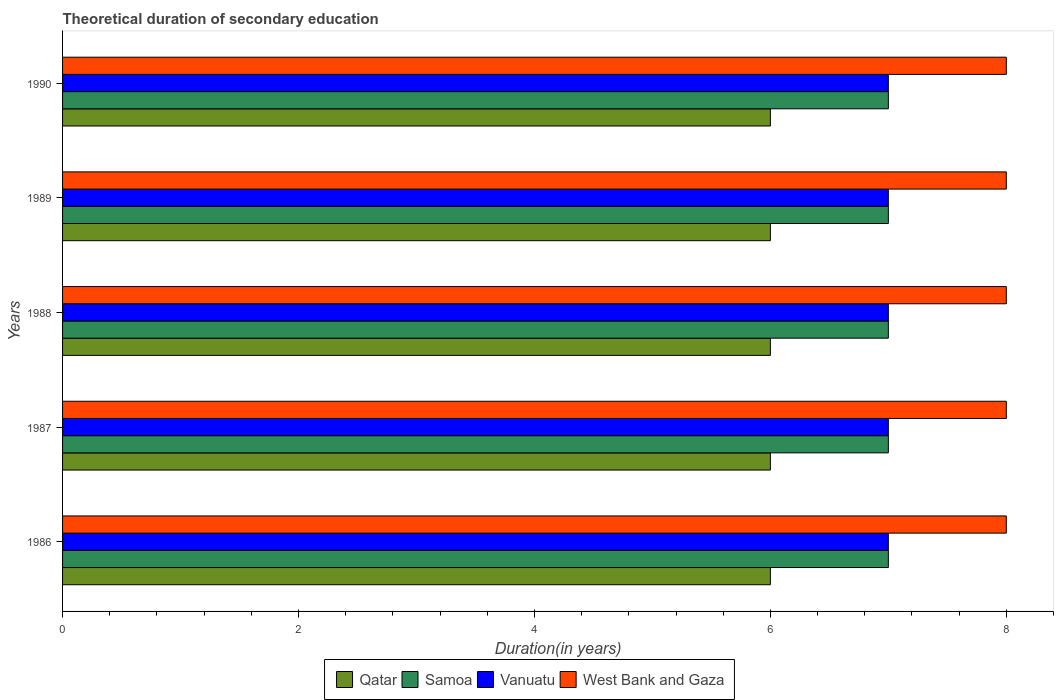How many different coloured bars are there?
Give a very brief answer. 4. Are the number of bars per tick equal to the number of legend labels?
Offer a terse response. Yes. How many bars are there on the 5th tick from the top?
Ensure brevity in your answer.  4. What is the label of the 1st group of bars from the top?
Your response must be concise. 1990. In how many cases, is the number of bars for a given year not equal to the number of legend labels?
Ensure brevity in your answer.  0. What is the total theoretical duration of secondary education in West Bank and Gaza in 1987?
Ensure brevity in your answer.  8. Across all years, what is the maximum total theoretical duration of secondary education in Vanuatu?
Give a very brief answer. 7. Across all years, what is the minimum total theoretical duration of secondary education in West Bank and Gaza?
Your answer should be compact. 8. In which year was the total theoretical duration of secondary education in West Bank and Gaza minimum?
Your answer should be compact. 1986. What is the total total theoretical duration of secondary education in Qatar in the graph?
Provide a succinct answer. 30. What is the difference between the total theoretical duration of secondary education in Samoa in 1988 and that in 1990?
Give a very brief answer. 0. What is the difference between the total theoretical duration of secondary education in West Bank and Gaza in 1989 and the total theoretical duration of secondary education in Vanuatu in 1986?
Provide a succinct answer. 1. In the year 1990, what is the difference between the total theoretical duration of secondary education in Vanuatu and total theoretical duration of secondary education in West Bank and Gaza?
Provide a short and direct response. -1. What is the ratio of the total theoretical duration of secondary education in Qatar in 1986 to that in 1990?
Provide a short and direct response. 1. Is the difference between the total theoretical duration of secondary education in Vanuatu in 1988 and 1990 greater than the difference between the total theoretical duration of secondary education in West Bank and Gaza in 1988 and 1990?
Your answer should be very brief. No. What is the difference between the highest and the second highest total theoretical duration of secondary education in Qatar?
Provide a short and direct response. 0. Is it the case that in every year, the sum of the total theoretical duration of secondary education in Samoa and total theoretical duration of secondary education in West Bank and Gaza is greater than the sum of total theoretical duration of secondary education in Vanuatu and total theoretical duration of secondary education in Qatar?
Make the answer very short. No. What does the 2nd bar from the top in 1986 represents?
Provide a succinct answer. Vanuatu. What does the 3rd bar from the bottom in 1990 represents?
Offer a very short reply. Vanuatu. How many bars are there?
Offer a very short reply. 20. Are all the bars in the graph horizontal?
Offer a terse response. Yes. Does the graph contain any zero values?
Provide a short and direct response. No. Does the graph contain grids?
Give a very brief answer. No. How are the legend labels stacked?
Offer a very short reply. Horizontal. What is the title of the graph?
Make the answer very short. Theoretical duration of secondary education. What is the label or title of the X-axis?
Give a very brief answer. Duration(in years). What is the label or title of the Y-axis?
Your answer should be very brief. Years. What is the Duration(in years) of Qatar in 1986?
Keep it short and to the point. 6. What is the Duration(in years) in Vanuatu in 1986?
Offer a terse response. 7. What is the Duration(in years) in Qatar in 1987?
Your answer should be compact. 6. What is the Duration(in years) of Vanuatu in 1987?
Your answer should be very brief. 7. What is the Duration(in years) in Vanuatu in 1988?
Your response must be concise. 7. What is the Duration(in years) in Vanuatu in 1990?
Your answer should be compact. 7. What is the Duration(in years) of West Bank and Gaza in 1990?
Make the answer very short. 8. Across all years, what is the maximum Duration(in years) of Qatar?
Offer a very short reply. 6. Across all years, what is the maximum Duration(in years) of Vanuatu?
Keep it short and to the point. 7. Across all years, what is the minimum Duration(in years) in Qatar?
Provide a short and direct response. 6. Across all years, what is the minimum Duration(in years) of West Bank and Gaza?
Provide a succinct answer. 8. What is the total Duration(in years) in Qatar in the graph?
Provide a succinct answer. 30. What is the total Duration(in years) in Samoa in the graph?
Make the answer very short. 35. What is the total Duration(in years) in Vanuatu in the graph?
Offer a terse response. 35. What is the difference between the Duration(in years) of Samoa in 1986 and that in 1987?
Your response must be concise. 0. What is the difference between the Duration(in years) of Vanuatu in 1986 and that in 1987?
Keep it short and to the point. 0. What is the difference between the Duration(in years) in West Bank and Gaza in 1986 and that in 1987?
Offer a terse response. 0. What is the difference between the Duration(in years) in Qatar in 1986 and that in 1988?
Give a very brief answer. 0. What is the difference between the Duration(in years) in Samoa in 1986 and that in 1988?
Your answer should be compact. 0. What is the difference between the Duration(in years) in Vanuatu in 1986 and that in 1988?
Your response must be concise. 0. What is the difference between the Duration(in years) in Samoa in 1986 and that in 1989?
Your answer should be compact. 0. What is the difference between the Duration(in years) in Vanuatu in 1986 and that in 1989?
Your answer should be very brief. 0. What is the difference between the Duration(in years) of West Bank and Gaza in 1986 and that in 1990?
Provide a short and direct response. 0. What is the difference between the Duration(in years) in Qatar in 1987 and that in 1988?
Ensure brevity in your answer.  0. What is the difference between the Duration(in years) in Samoa in 1987 and that in 1988?
Provide a short and direct response. 0. What is the difference between the Duration(in years) of West Bank and Gaza in 1987 and that in 1988?
Offer a very short reply. 0. What is the difference between the Duration(in years) in Qatar in 1987 and that in 1990?
Give a very brief answer. 0. What is the difference between the Duration(in years) in Samoa in 1987 and that in 1990?
Ensure brevity in your answer.  0. What is the difference between the Duration(in years) of Qatar in 1988 and that in 1989?
Ensure brevity in your answer.  0. What is the difference between the Duration(in years) of Samoa in 1988 and that in 1989?
Offer a very short reply. 0. What is the difference between the Duration(in years) in Vanuatu in 1988 and that in 1989?
Provide a succinct answer. 0. What is the difference between the Duration(in years) of West Bank and Gaza in 1988 and that in 1989?
Provide a short and direct response. 0. What is the difference between the Duration(in years) in West Bank and Gaza in 1988 and that in 1990?
Offer a terse response. 0. What is the difference between the Duration(in years) in Samoa in 1989 and that in 1990?
Offer a very short reply. 0. What is the difference between the Duration(in years) of West Bank and Gaza in 1989 and that in 1990?
Offer a terse response. 0. What is the difference between the Duration(in years) in Vanuatu in 1986 and the Duration(in years) in West Bank and Gaza in 1987?
Your response must be concise. -1. What is the difference between the Duration(in years) in Qatar in 1986 and the Duration(in years) in Vanuatu in 1988?
Keep it short and to the point. -1. What is the difference between the Duration(in years) in Qatar in 1986 and the Duration(in years) in West Bank and Gaza in 1988?
Give a very brief answer. -2. What is the difference between the Duration(in years) in Samoa in 1986 and the Duration(in years) in West Bank and Gaza in 1988?
Your answer should be compact. -1. What is the difference between the Duration(in years) of Qatar in 1986 and the Duration(in years) of Vanuatu in 1989?
Make the answer very short. -1. What is the difference between the Duration(in years) in Samoa in 1986 and the Duration(in years) in West Bank and Gaza in 1989?
Keep it short and to the point. -1. What is the difference between the Duration(in years) in Vanuatu in 1986 and the Duration(in years) in West Bank and Gaza in 1989?
Provide a succinct answer. -1. What is the difference between the Duration(in years) in Samoa in 1986 and the Duration(in years) in Vanuatu in 1990?
Provide a succinct answer. 0. What is the difference between the Duration(in years) in Samoa in 1986 and the Duration(in years) in West Bank and Gaza in 1990?
Give a very brief answer. -1. What is the difference between the Duration(in years) of Vanuatu in 1986 and the Duration(in years) of West Bank and Gaza in 1990?
Provide a succinct answer. -1. What is the difference between the Duration(in years) of Qatar in 1987 and the Duration(in years) of Samoa in 1988?
Ensure brevity in your answer.  -1. What is the difference between the Duration(in years) of Qatar in 1987 and the Duration(in years) of Vanuatu in 1988?
Your answer should be very brief. -1. What is the difference between the Duration(in years) of Qatar in 1987 and the Duration(in years) of West Bank and Gaza in 1988?
Your answer should be very brief. -2. What is the difference between the Duration(in years) of Samoa in 1987 and the Duration(in years) of West Bank and Gaza in 1988?
Your answer should be compact. -1. What is the difference between the Duration(in years) of Vanuatu in 1987 and the Duration(in years) of West Bank and Gaza in 1988?
Provide a short and direct response. -1. What is the difference between the Duration(in years) in Qatar in 1987 and the Duration(in years) in Samoa in 1989?
Offer a terse response. -1. What is the difference between the Duration(in years) of Qatar in 1987 and the Duration(in years) of West Bank and Gaza in 1989?
Your answer should be compact. -2. What is the difference between the Duration(in years) of Samoa in 1987 and the Duration(in years) of West Bank and Gaza in 1989?
Your response must be concise. -1. What is the difference between the Duration(in years) of Qatar in 1987 and the Duration(in years) of Samoa in 1990?
Provide a short and direct response. -1. What is the difference between the Duration(in years) of Qatar in 1987 and the Duration(in years) of Vanuatu in 1990?
Your response must be concise. -1. What is the difference between the Duration(in years) of Samoa in 1987 and the Duration(in years) of West Bank and Gaza in 1990?
Make the answer very short. -1. What is the difference between the Duration(in years) in Qatar in 1988 and the Duration(in years) in Vanuatu in 1989?
Give a very brief answer. -1. What is the difference between the Duration(in years) of Qatar in 1988 and the Duration(in years) of Vanuatu in 1990?
Make the answer very short. -1. What is the difference between the Duration(in years) in Qatar in 1988 and the Duration(in years) in West Bank and Gaza in 1990?
Keep it short and to the point. -2. What is the difference between the Duration(in years) in Samoa in 1988 and the Duration(in years) in Vanuatu in 1990?
Your response must be concise. 0. What is the difference between the Duration(in years) of Vanuatu in 1988 and the Duration(in years) of West Bank and Gaza in 1990?
Provide a short and direct response. -1. What is the difference between the Duration(in years) in Qatar in 1989 and the Duration(in years) in Samoa in 1990?
Provide a succinct answer. -1. What is the difference between the Duration(in years) of Qatar in 1989 and the Duration(in years) of Vanuatu in 1990?
Make the answer very short. -1. What is the difference between the Duration(in years) in Vanuatu in 1989 and the Duration(in years) in West Bank and Gaza in 1990?
Give a very brief answer. -1. What is the average Duration(in years) of West Bank and Gaza per year?
Offer a very short reply. 8. In the year 1986, what is the difference between the Duration(in years) of Qatar and Duration(in years) of Samoa?
Offer a terse response. -1. In the year 1986, what is the difference between the Duration(in years) of Samoa and Duration(in years) of Vanuatu?
Ensure brevity in your answer.  0. In the year 1986, what is the difference between the Duration(in years) of Samoa and Duration(in years) of West Bank and Gaza?
Provide a short and direct response. -1. In the year 1986, what is the difference between the Duration(in years) in Vanuatu and Duration(in years) in West Bank and Gaza?
Your answer should be compact. -1. In the year 1987, what is the difference between the Duration(in years) of Qatar and Duration(in years) of Samoa?
Your answer should be compact. -1. In the year 1987, what is the difference between the Duration(in years) of Vanuatu and Duration(in years) of West Bank and Gaza?
Offer a very short reply. -1. In the year 1988, what is the difference between the Duration(in years) in Qatar and Duration(in years) in Samoa?
Offer a very short reply. -1. In the year 1988, what is the difference between the Duration(in years) in Qatar and Duration(in years) in Vanuatu?
Your answer should be compact. -1. In the year 1988, what is the difference between the Duration(in years) in Qatar and Duration(in years) in West Bank and Gaza?
Provide a succinct answer. -2. In the year 1988, what is the difference between the Duration(in years) in Samoa and Duration(in years) in Vanuatu?
Provide a succinct answer. 0. In the year 1988, what is the difference between the Duration(in years) in Vanuatu and Duration(in years) in West Bank and Gaza?
Make the answer very short. -1. In the year 1989, what is the difference between the Duration(in years) in Vanuatu and Duration(in years) in West Bank and Gaza?
Offer a terse response. -1. In the year 1990, what is the difference between the Duration(in years) in Qatar and Duration(in years) in Samoa?
Provide a short and direct response. -1. In the year 1990, what is the difference between the Duration(in years) in Vanuatu and Duration(in years) in West Bank and Gaza?
Provide a succinct answer. -1. What is the ratio of the Duration(in years) in Qatar in 1986 to that in 1987?
Your answer should be compact. 1. What is the ratio of the Duration(in years) of Samoa in 1986 to that in 1987?
Your answer should be compact. 1. What is the ratio of the Duration(in years) in Vanuatu in 1986 to that in 1987?
Make the answer very short. 1. What is the ratio of the Duration(in years) in Qatar in 1986 to that in 1988?
Keep it short and to the point. 1. What is the ratio of the Duration(in years) of Vanuatu in 1986 to that in 1988?
Provide a short and direct response. 1. What is the ratio of the Duration(in years) in West Bank and Gaza in 1986 to that in 1988?
Ensure brevity in your answer.  1. What is the ratio of the Duration(in years) of Qatar in 1986 to that in 1989?
Your answer should be very brief. 1. What is the ratio of the Duration(in years) in Vanuatu in 1986 to that in 1989?
Give a very brief answer. 1. What is the ratio of the Duration(in years) in Samoa in 1986 to that in 1990?
Provide a short and direct response. 1. What is the ratio of the Duration(in years) of West Bank and Gaza in 1986 to that in 1990?
Keep it short and to the point. 1. What is the ratio of the Duration(in years) of Qatar in 1987 to that in 1988?
Your response must be concise. 1. What is the ratio of the Duration(in years) in Vanuatu in 1987 to that in 1988?
Make the answer very short. 1. What is the ratio of the Duration(in years) in Samoa in 1987 to that in 1989?
Your response must be concise. 1. What is the ratio of the Duration(in years) of Vanuatu in 1987 to that in 1989?
Your response must be concise. 1. What is the ratio of the Duration(in years) in West Bank and Gaza in 1987 to that in 1989?
Offer a terse response. 1. What is the ratio of the Duration(in years) in Qatar in 1987 to that in 1990?
Make the answer very short. 1. What is the ratio of the Duration(in years) in Samoa in 1987 to that in 1990?
Your response must be concise. 1. What is the ratio of the Duration(in years) in Vanuatu in 1987 to that in 1990?
Provide a succinct answer. 1. What is the ratio of the Duration(in years) in Qatar in 1988 to that in 1989?
Provide a succinct answer. 1. What is the ratio of the Duration(in years) in Samoa in 1988 to that in 1989?
Your answer should be very brief. 1. What is the ratio of the Duration(in years) of West Bank and Gaza in 1988 to that in 1989?
Your answer should be very brief. 1. What is the ratio of the Duration(in years) of Qatar in 1988 to that in 1990?
Your answer should be very brief. 1. What is the ratio of the Duration(in years) in Samoa in 1988 to that in 1990?
Your response must be concise. 1. What is the ratio of the Duration(in years) in Vanuatu in 1988 to that in 1990?
Make the answer very short. 1. What is the ratio of the Duration(in years) of West Bank and Gaza in 1988 to that in 1990?
Provide a short and direct response. 1. What is the ratio of the Duration(in years) in Qatar in 1989 to that in 1990?
Your response must be concise. 1. What is the ratio of the Duration(in years) of Samoa in 1989 to that in 1990?
Ensure brevity in your answer.  1. What is the ratio of the Duration(in years) of Vanuatu in 1989 to that in 1990?
Keep it short and to the point. 1. What is the ratio of the Duration(in years) in West Bank and Gaza in 1989 to that in 1990?
Make the answer very short. 1. What is the difference between the highest and the second highest Duration(in years) in Qatar?
Your answer should be very brief. 0. What is the difference between the highest and the second highest Duration(in years) in Vanuatu?
Ensure brevity in your answer.  0. What is the difference between the highest and the lowest Duration(in years) in Qatar?
Ensure brevity in your answer.  0. What is the difference between the highest and the lowest Duration(in years) in Samoa?
Keep it short and to the point. 0. What is the difference between the highest and the lowest Duration(in years) of Vanuatu?
Offer a very short reply. 0. 